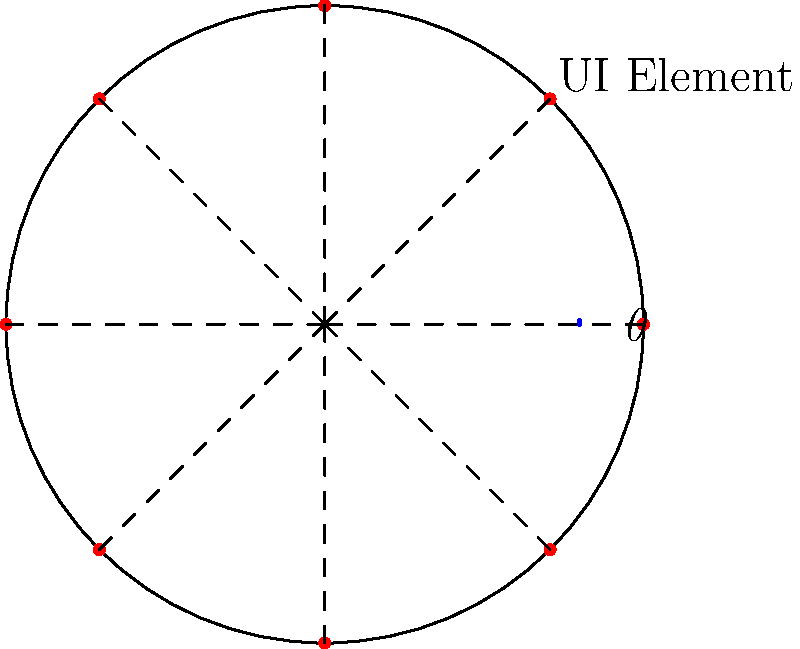As a web developer working on a circular menu design for a Java EE application, you need to determine the optimal angle between UI elements for even spacing. Given a circular menu with 8 UI elements, what is the angle $\theta$ (in degrees) between each element? To determine the optimal angle between UI elements in a circular menu, we can follow these steps:

1. Recognize that a full circle contains 360° or $2\pi$ radians.

2. Given that we have 8 UI elements, we need to divide the full circle equally among these elements.

3. Calculate the angle $\theta$ in radians:
   $\theta = \frac{2\pi}{8} = \frac{\pi}{4}$ radians

4. Convert the angle from radians to degrees:
   $\theta_{degrees} = \frac{\pi}{4} \cdot \frac{180°}{\pi} = 45°$

Therefore, the optimal angle between each UI element in the circular menu with 8 elements is 45°.
Answer: 45° 